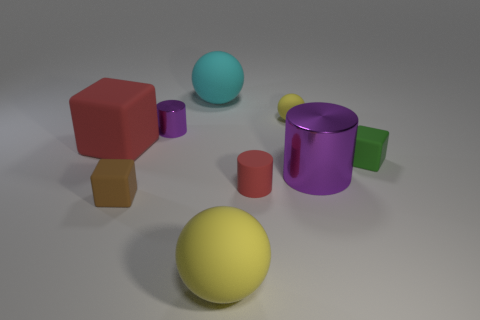Are there any patterns or text on the objects? No, all the objects are solid colors with no discernible patterns or text. 